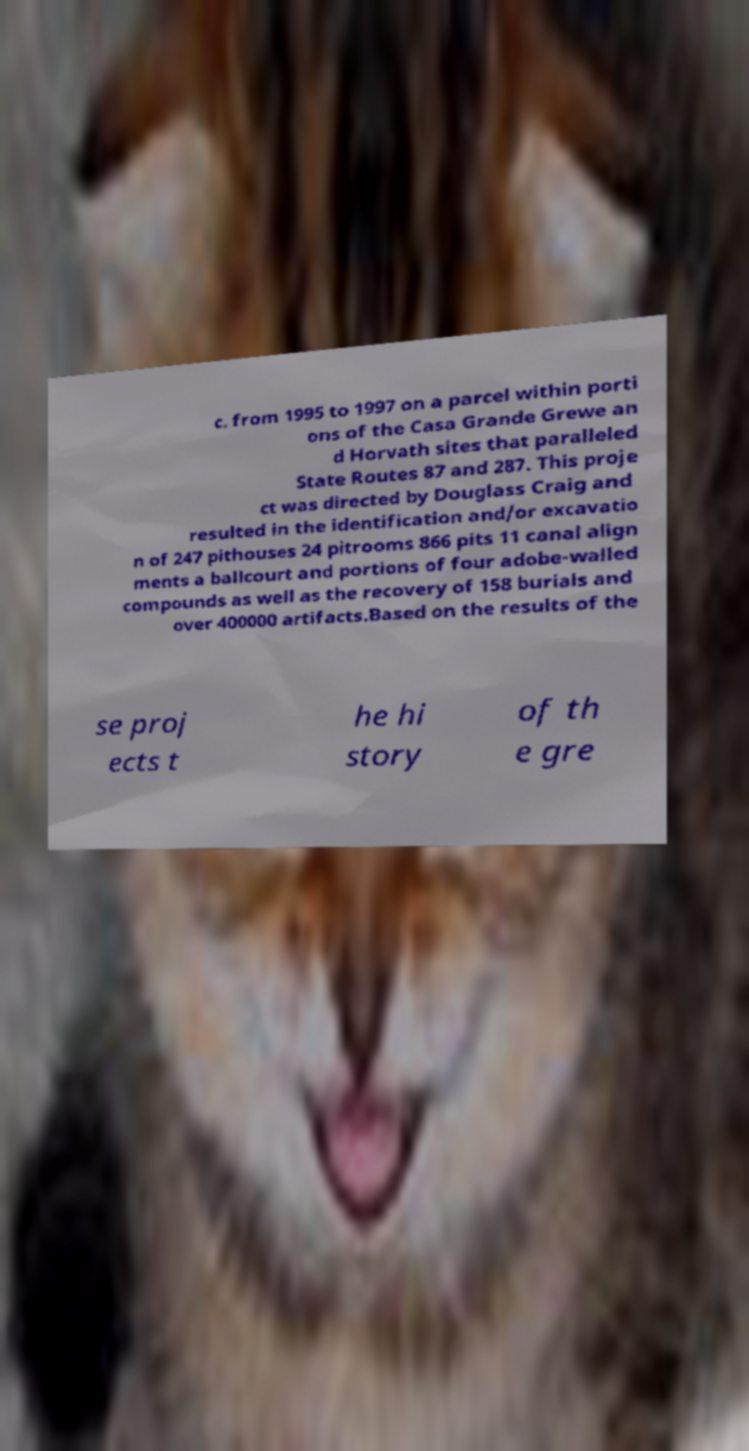Please read and relay the text visible in this image. What does it say? c. from 1995 to 1997 on a parcel within porti ons of the Casa Grande Grewe an d Horvath sites that paralleled State Routes 87 and 287. This proje ct was directed by Douglass Craig and resulted in the identification and/or excavatio n of 247 pithouses 24 pitrooms 866 pits 11 canal align ments a ballcourt and portions of four adobe-walled compounds as well as the recovery of 158 burials and over 400000 artifacts.Based on the results of the se proj ects t he hi story of th e gre 